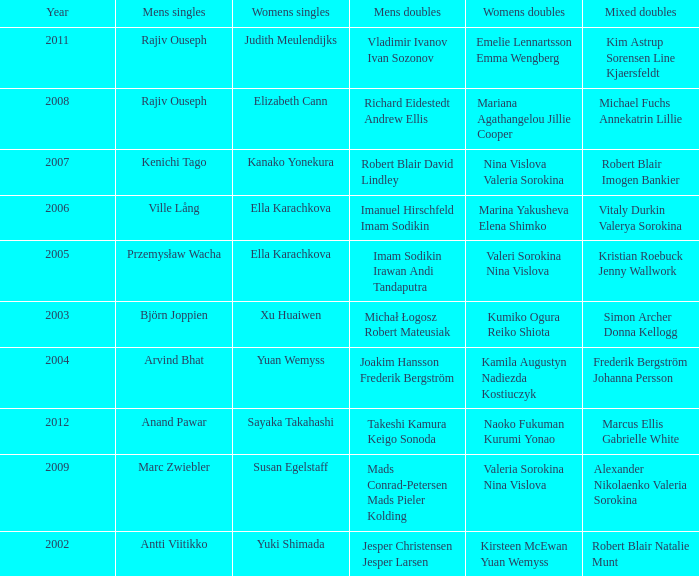What are the womens singles of imam sodikin irawan andi tandaputra? Ella Karachkova. 